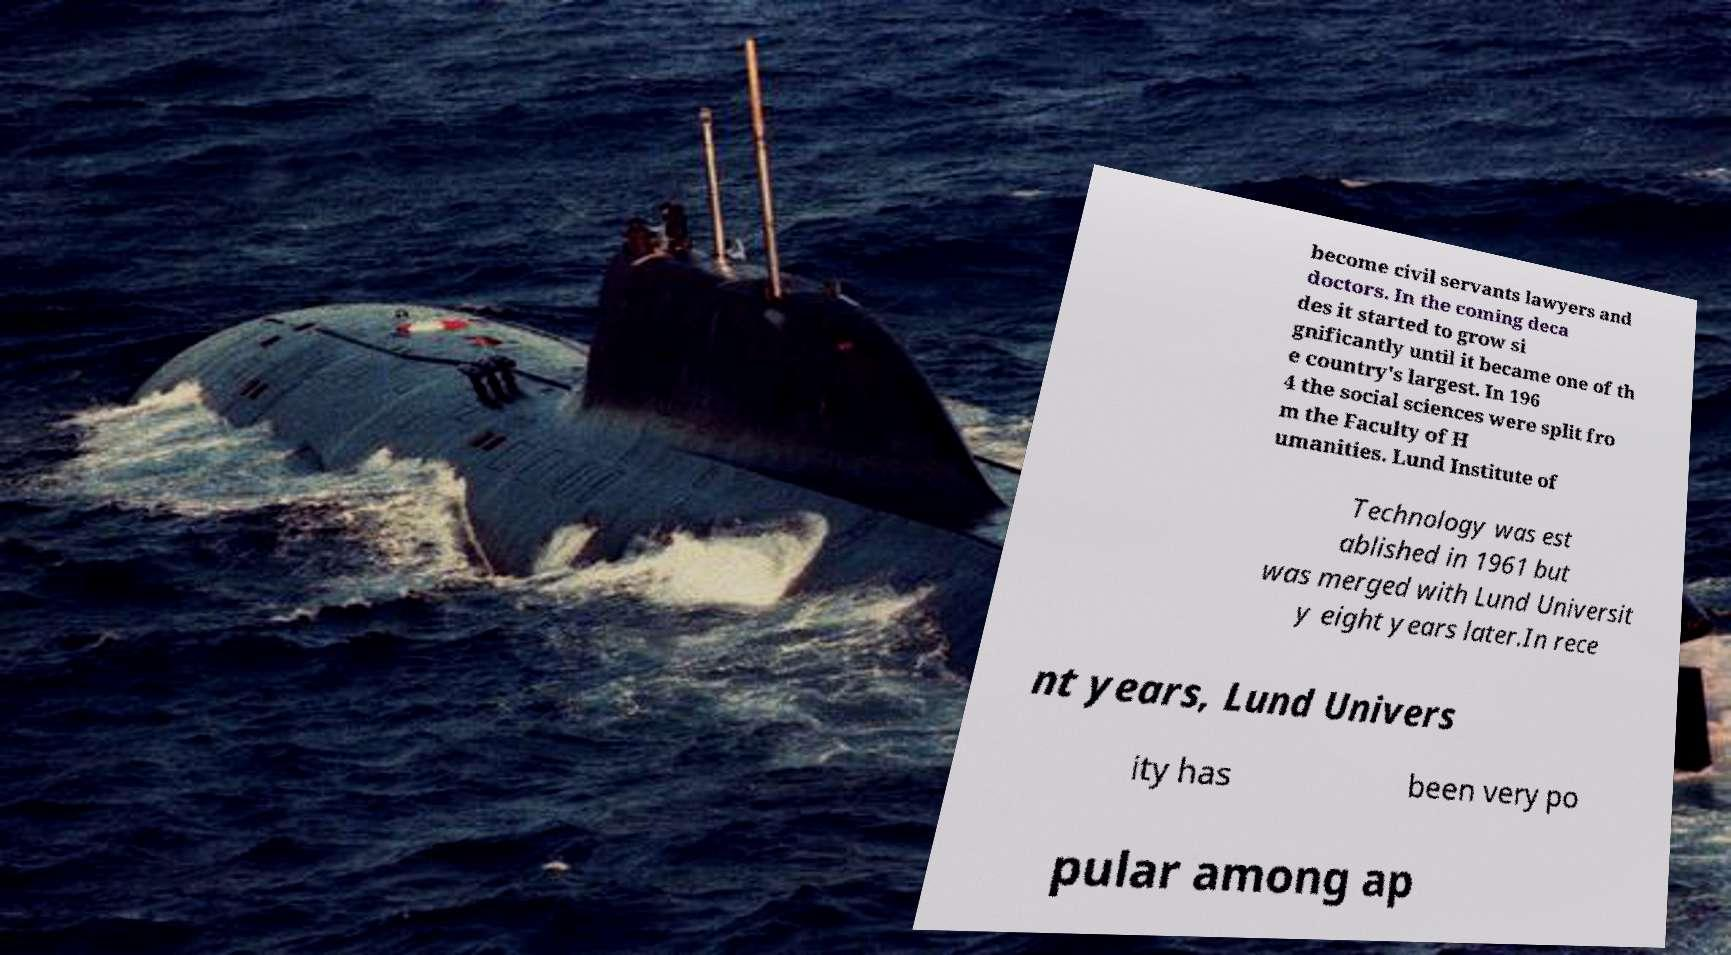For documentation purposes, I need the text within this image transcribed. Could you provide that? become civil servants lawyers and doctors. In the coming deca des it started to grow si gnificantly until it became one of th e country's largest. In 196 4 the social sciences were split fro m the Faculty of H umanities. Lund Institute of Technology was est ablished in 1961 but was merged with Lund Universit y eight years later.In rece nt years, Lund Univers ity has been very po pular among ap 